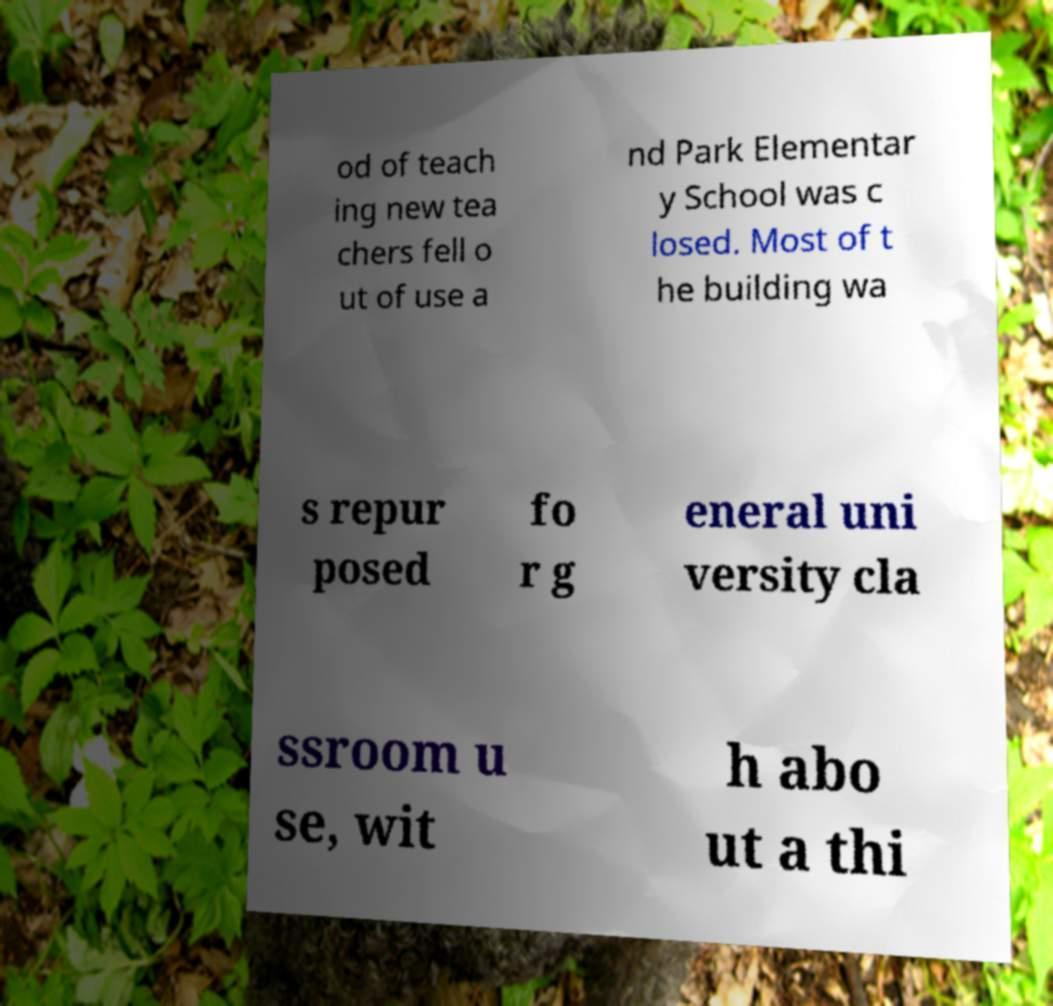I need the written content from this picture converted into text. Can you do that? od of teach ing new tea chers fell o ut of use a nd Park Elementar y School was c losed. Most of t he building wa s repur posed fo r g eneral uni versity cla ssroom u se, wit h abo ut a thi 